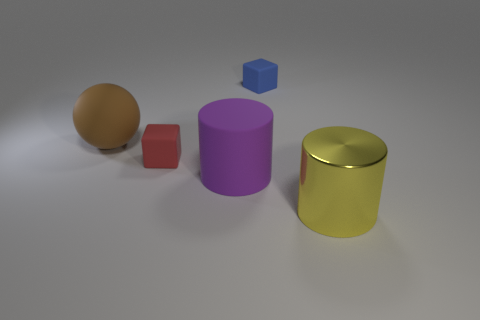Is there any other thing that has the same material as the yellow thing?
Provide a succinct answer. No. Is there a yellow shiny block?
Provide a succinct answer. No. What number of tiny objects are blue blocks or balls?
Ensure brevity in your answer.  1. Are there more big purple matte objects in front of the rubber sphere than brown things that are on the right side of the small blue object?
Keep it short and to the point. Yes. Does the large brown sphere have the same material as the tiny object in front of the small blue thing?
Your response must be concise. Yes. What color is the metal object?
Offer a terse response. Yellow. There is a small object left of the large rubber cylinder; what shape is it?
Offer a very short reply. Cube. What number of blue things are shiny cylinders or large spheres?
Your response must be concise. 0. The ball that is made of the same material as the big purple object is what color?
Provide a short and direct response. Brown. What is the color of the matte thing that is in front of the brown ball and right of the small red cube?
Your response must be concise. Purple. 